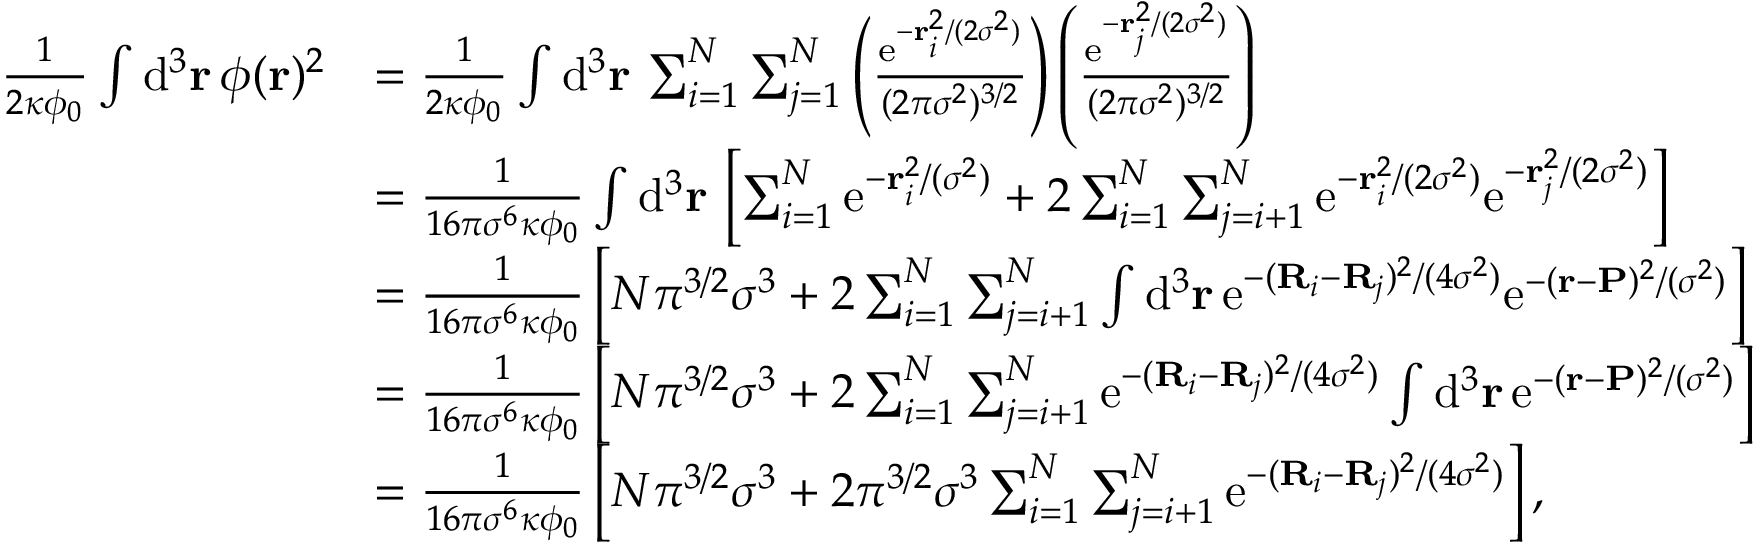Convert formula to latex. <formula><loc_0><loc_0><loc_500><loc_500>\begin{array} { r l } { \frac { 1 } { 2 \kappa \phi _ { 0 } } \int d ^ { 3 } r \, \phi ( r ) ^ { 2 } } & { = \frac { 1 } { 2 \kappa \phi _ { 0 } } \int d ^ { 3 } r \, \sum _ { i = 1 } ^ { N } \sum _ { j = 1 } ^ { N } \left ( \frac { e ^ { - r _ { i } ^ { 2 } / ( 2 \sigma ^ { 2 } ) } } { ( 2 \pi \sigma ^ { 2 } ) ^ { 3 / 2 } } \right ) \left ( \frac { e ^ { - r _ { j } ^ { 2 } / ( 2 \sigma ^ { 2 } ) } } { ( 2 \pi \sigma ^ { 2 } ) ^ { 3 / 2 } } \right ) } \\ & { = \frac { 1 } { 1 6 \pi \sigma ^ { 6 } \kappa \phi _ { 0 } } \int d ^ { 3 } r \, \left [ \sum _ { i = 1 } ^ { N } e ^ { - r _ { i } ^ { 2 } / ( \sigma ^ { 2 } ) } + 2 \sum _ { i = 1 } ^ { N } \sum _ { j = i + 1 } ^ { N } e ^ { - r _ { i } ^ { 2 } / ( 2 \sigma ^ { 2 } ) } e ^ { - r _ { j } ^ { 2 } / ( 2 \sigma ^ { 2 } ) } \right ] } \\ & { = \frac { 1 } { 1 6 \pi \sigma ^ { 6 } \kappa \phi _ { 0 } } \left [ N \pi ^ { 3 / 2 } \sigma ^ { 3 } + 2 \sum _ { i = 1 } ^ { N } \sum _ { j = i + 1 } ^ { N } \int d ^ { 3 } r \, e ^ { - ( R _ { i } - R _ { j } ) ^ { 2 } / ( 4 \sigma ^ { 2 } ) } e ^ { - ( r - P ) ^ { 2 } / ( \sigma ^ { 2 } ) } \right ] } \\ & { = \frac { 1 } { 1 6 \pi \sigma ^ { 6 } \kappa \phi _ { 0 } } \left [ N \pi ^ { 3 / 2 } \sigma ^ { 3 } + 2 \sum _ { i = 1 } ^ { N } \sum _ { j = i + 1 } ^ { N } e ^ { - ( R _ { i } - R _ { j } ) ^ { 2 } / ( 4 \sigma ^ { 2 } ) } \int d ^ { 3 } r \, e ^ { - ( r - P ) ^ { 2 } / ( \sigma ^ { 2 } ) } \right ] } \\ & { = \frac { 1 } { 1 6 \pi \sigma ^ { 6 } \kappa \phi _ { 0 } } \left [ N \pi ^ { 3 / 2 } \sigma ^ { 3 } + 2 \pi ^ { 3 / 2 } \sigma ^ { 3 } \sum _ { i = 1 } ^ { N } \sum _ { j = i + 1 } ^ { N } e ^ { - ( R _ { i } - R _ { j } ) ^ { 2 } / ( 4 \sigma ^ { 2 } ) } \right ] , } \end{array}</formula> 